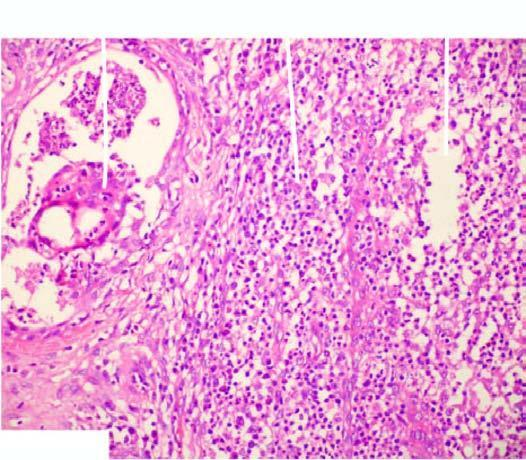s the affected area on right presence of a lipogranuloma having central pool of fat and surrounded by mixed inflammatory cells and foreign body type multinucleated giant cells?
Answer the question using a single word or phrase. No 